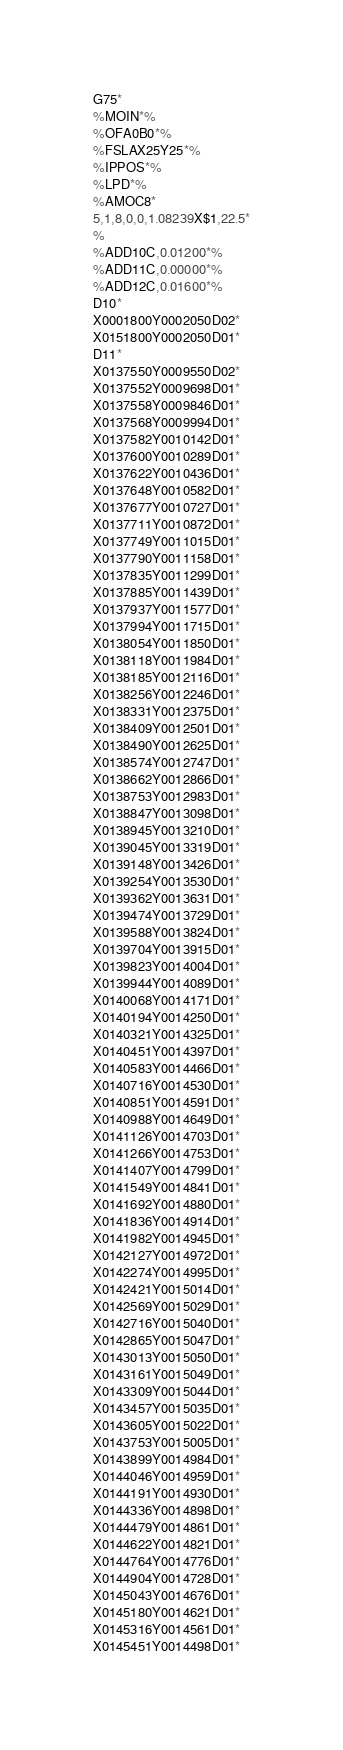Convert code to text. <code><loc_0><loc_0><loc_500><loc_500><_SQL_>G75*
%MOIN*%
%OFA0B0*%
%FSLAX25Y25*%
%IPPOS*%
%LPD*%
%AMOC8*
5,1,8,0,0,1.08239X$1,22.5*
%
%ADD10C,0.01200*%
%ADD11C,0.00000*%
%ADD12C,0.01600*%
D10*
X0001800Y0002050D02*
X0151800Y0002050D01*
D11*
X0137550Y0009550D02*
X0137552Y0009698D01*
X0137558Y0009846D01*
X0137568Y0009994D01*
X0137582Y0010142D01*
X0137600Y0010289D01*
X0137622Y0010436D01*
X0137648Y0010582D01*
X0137677Y0010727D01*
X0137711Y0010872D01*
X0137749Y0011015D01*
X0137790Y0011158D01*
X0137835Y0011299D01*
X0137885Y0011439D01*
X0137937Y0011577D01*
X0137994Y0011715D01*
X0138054Y0011850D01*
X0138118Y0011984D01*
X0138185Y0012116D01*
X0138256Y0012246D01*
X0138331Y0012375D01*
X0138409Y0012501D01*
X0138490Y0012625D01*
X0138574Y0012747D01*
X0138662Y0012866D01*
X0138753Y0012983D01*
X0138847Y0013098D01*
X0138945Y0013210D01*
X0139045Y0013319D01*
X0139148Y0013426D01*
X0139254Y0013530D01*
X0139362Y0013631D01*
X0139474Y0013729D01*
X0139588Y0013824D01*
X0139704Y0013915D01*
X0139823Y0014004D01*
X0139944Y0014089D01*
X0140068Y0014171D01*
X0140194Y0014250D01*
X0140321Y0014325D01*
X0140451Y0014397D01*
X0140583Y0014466D01*
X0140716Y0014530D01*
X0140851Y0014591D01*
X0140988Y0014649D01*
X0141126Y0014703D01*
X0141266Y0014753D01*
X0141407Y0014799D01*
X0141549Y0014841D01*
X0141692Y0014880D01*
X0141836Y0014914D01*
X0141982Y0014945D01*
X0142127Y0014972D01*
X0142274Y0014995D01*
X0142421Y0015014D01*
X0142569Y0015029D01*
X0142716Y0015040D01*
X0142865Y0015047D01*
X0143013Y0015050D01*
X0143161Y0015049D01*
X0143309Y0015044D01*
X0143457Y0015035D01*
X0143605Y0015022D01*
X0143753Y0015005D01*
X0143899Y0014984D01*
X0144046Y0014959D01*
X0144191Y0014930D01*
X0144336Y0014898D01*
X0144479Y0014861D01*
X0144622Y0014821D01*
X0144764Y0014776D01*
X0144904Y0014728D01*
X0145043Y0014676D01*
X0145180Y0014621D01*
X0145316Y0014561D01*
X0145451Y0014498D01*</code> 